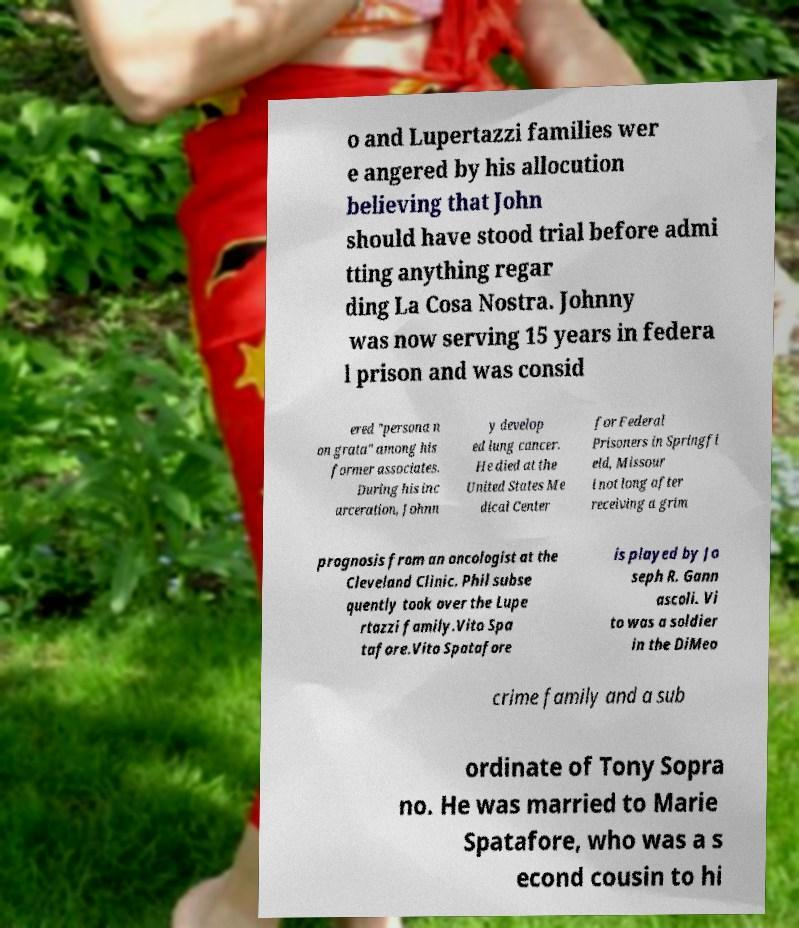Can you accurately transcribe the text from the provided image for me? o and Lupertazzi families wer e angered by his allocution believing that John should have stood trial before admi tting anything regar ding La Cosa Nostra. Johnny was now serving 15 years in federa l prison and was consid ered "persona n on grata" among his former associates. During his inc arceration, Johnn y develop ed lung cancer. He died at the United States Me dical Center for Federal Prisoners in Springfi eld, Missour i not long after receiving a grim prognosis from an oncologist at the Cleveland Clinic. Phil subse quently took over the Lupe rtazzi family.Vito Spa tafore.Vito Spatafore is played by Jo seph R. Gann ascoli. Vi to was a soldier in the DiMeo crime family and a sub ordinate of Tony Sopra no. He was married to Marie Spatafore, who was a s econd cousin to hi 